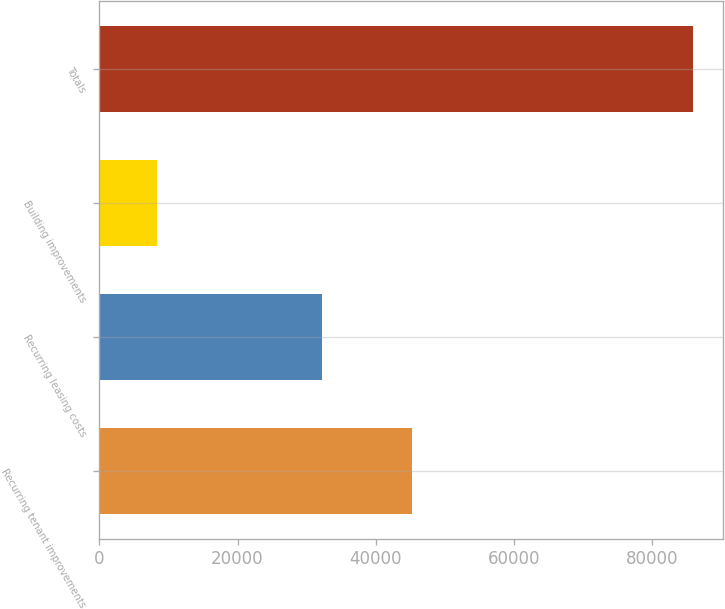<chart> <loc_0><loc_0><loc_500><loc_500><bar_chart><fcel>Recurring tenant improvements<fcel>Recurring leasing costs<fcel>Building improvements<fcel>Totals<nl><fcel>45296<fcel>32238<fcel>8402<fcel>85936<nl></chart> 